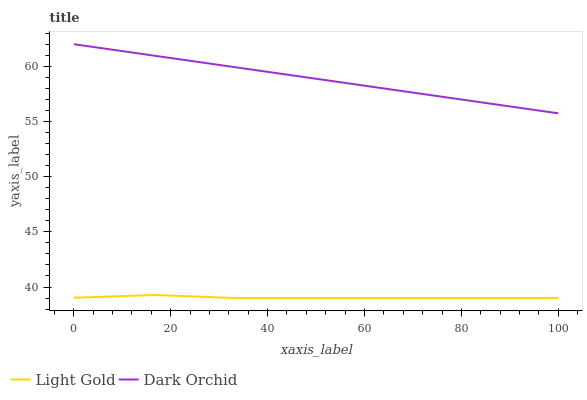Does Light Gold have the minimum area under the curve?
Answer yes or no. Yes. Does Dark Orchid have the maximum area under the curve?
Answer yes or no. Yes. Does Dark Orchid have the minimum area under the curve?
Answer yes or no. No. Is Dark Orchid the smoothest?
Answer yes or no. Yes. Is Light Gold the roughest?
Answer yes or no. Yes. Is Dark Orchid the roughest?
Answer yes or no. No. Does Light Gold have the lowest value?
Answer yes or no. Yes. Does Dark Orchid have the lowest value?
Answer yes or no. No. Does Dark Orchid have the highest value?
Answer yes or no. Yes. Is Light Gold less than Dark Orchid?
Answer yes or no. Yes. Is Dark Orchid greater than Light Gold?
Answer yes or no. Yes. Does Light Gold intersect Dark Orchid?
Answer yes or no. No. 